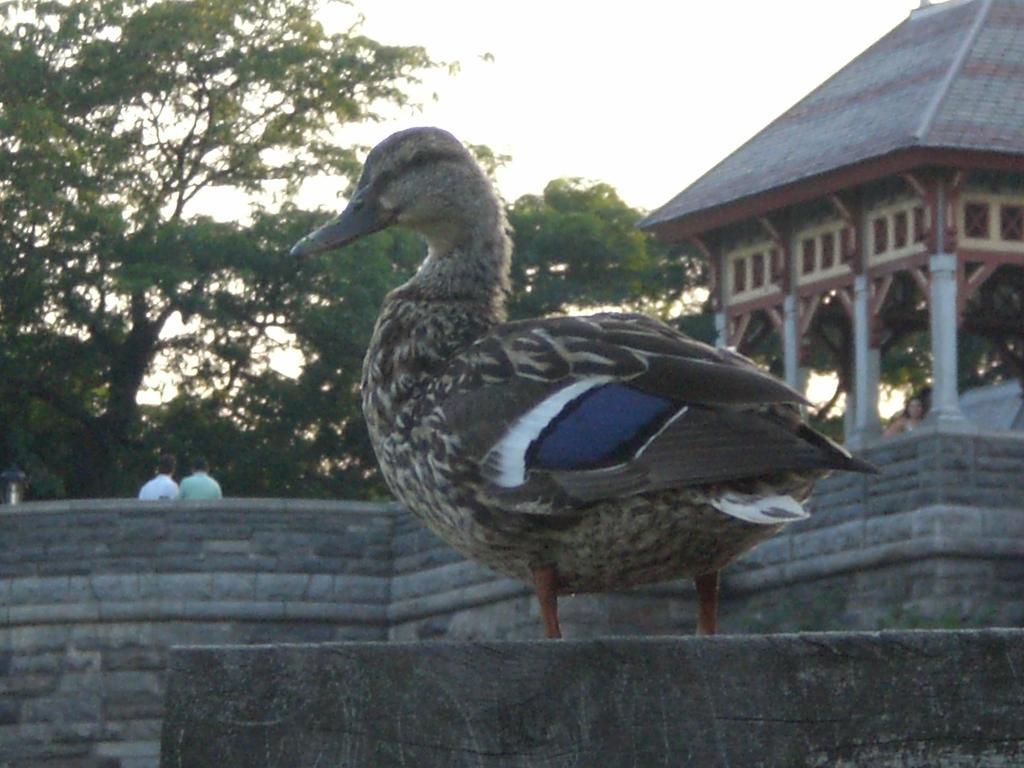In one or two sentences, can you explain what this image depicts? In this image, we can see a duck. Behind the duck, there is a wall, people, trees and an architecture. At the top of the image, there is the sky. 